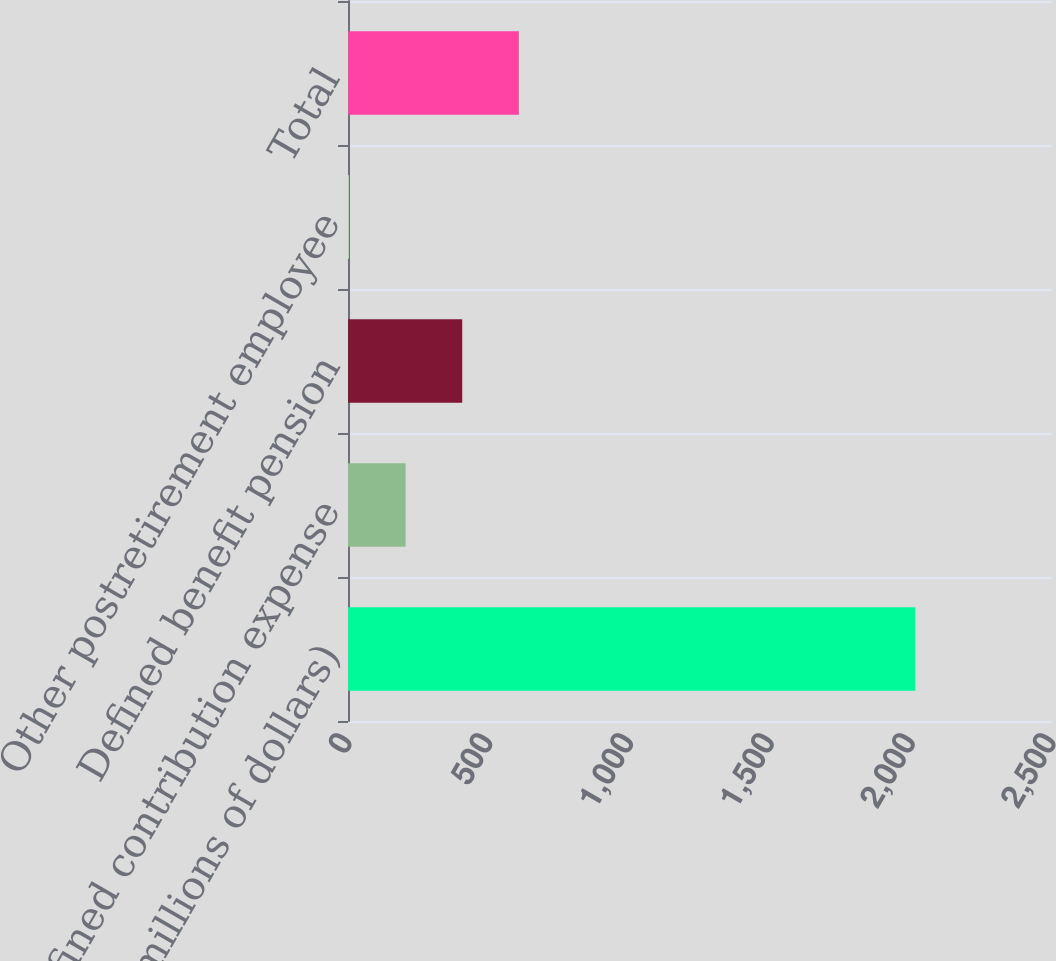Convert chart. <chart><loc_0><loc_0><loc_500><loc_500><bar_chart><fcel>(millions of dollars)<fcel>Defined contribution expense<fcel>Defined benefit pension<fcel>Other postretirement employee<fcel>Total<nl><fcel>2015<fcel>204.47<fcel>405.64<fcel>3.3<fcel>606.81<nl></chart> 